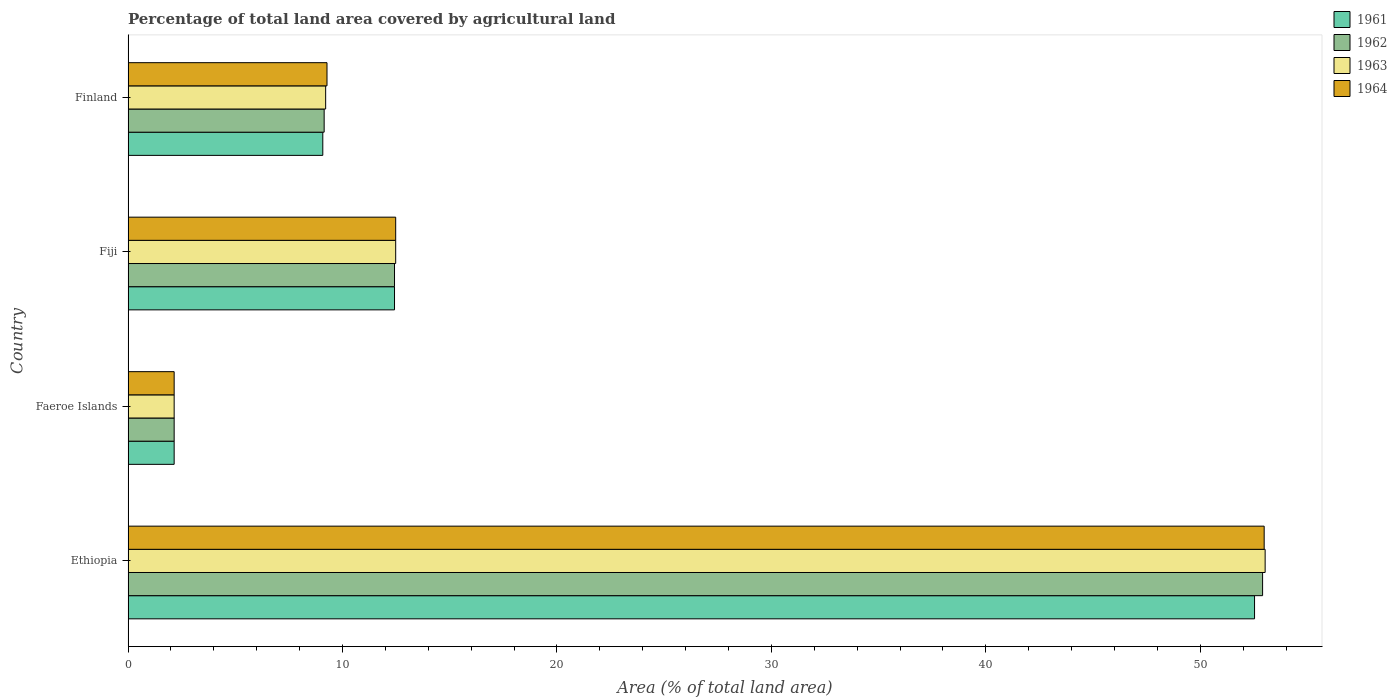How many groups of bars are there?
Keep it short and to the point. 4. Are the number of bars on each tick of the Y-axis equal?
Offer a very short reply. Yes. How many bars are there on the 2nd tick from the bottom?
Ensure brevity in your answer.  4. What is the label of the 4th group of bars from the top?
Keep it short and to the point. Ethiopia. In how many cases, is the number of bars for a given country not equal to the number of legend labels?
Give a very brief answer. 0. What is the percentage of agricultural land in 1961 in Ethiopia?
Keep it short and to the point. 52.53. Across all countries, what is the maximum percentage of agricultural land in 1964?
Give a very brief answer. 52.98. Across all countries, what is the minimum percentage of agricultural land in 1963?
Your answer should be very brief. 2.15. In which country was the percentage of agricultural land in 1963 maximum?
Ensure brevity in your answer.  Ethiopia. In which country was the percentage of agricultural land in 1961 minimum?
Your answer should be very brief. Faeroe Islands. What is the total percentage of agricultural land in 1963 in the graph?
Offer a terse response. 76.87. What is the difference between the percentage of agricultural land in 1961 in Fiji and that in Finland?
Ensure brevity in your answer.  3.34. What is the difference between the percentage of agricultural land in 1961 in Fiji and the percentage of agricultural land in 1964 in Ethiopia?
Provide a short and direct response. -40.55. What is the average percentage of agricultural land in 1964 per country?
Ensure brevity in your answer.  19.22. In how many countries, is the percentage of agricultural land in 1964 greater than 46 %?
Your answer should be very brief. 1. What is the ratio of the percentage of agricultural land in 1962 in Ethiopia to that in Faeroe Islands?
Offer a very short reply. 24.62. Is the difference between the percentage of agricultural land in 1963 in Faeroe Islands and Fiji greater than the difference between the percentage of agricultural land in 1962 in Faeroe Islands and Fiji?
Provide a succinct answer. No. What is the difference between the highest and the second highest percentage of agricultural land in 1963?
Your answer should be very brief. 40.55. What is the difference between the highest and the lowest percentage of agricultural land in 1962?
Provide a short and direct response. 50.76. Is the sum of the percentage of agricultural land in 1962 in Faeroe Islands and Fiji greater than the maximum percentage of agricultural land in 1964 across all countries?
Keep it short and to the point. No. Is it the case that in every country, the sum of the percentage of agricultural land in 1962 and percentage of agricultural land in 1964 is greater than the sum of percentage of agricultural land in 1963 and percentage of agricultural land in 1961?
Provide a succinct answer. No. What does the 4th bar from the bottom in Ethiopia represents?
Make the answer very short. 1964. How many bars are there?
Your answer should be compact. 16. Are all the bars in the graph horizontal?
Provide a succinct answer. Yes. Where does the legend appear in the graph?
Your response must be concise. Top right. How many legend labels are there?
Ensure brevity in your answer.  4. How are the legend labels stacked?
Provide a succinct answer. Vertical. What is the title of the graph?
Ensure brevity in your answer.  Percentage of total land area covered by agricultural land. What is the label or title of the X-axis?
Keep it short and to the point. Area (% of total land area). What is the Area (% of total land area) in 1961 in Ethiopia?
Your answer should be compact. 52.53. What is the Area (% of total land area) in 1962 in Ethiopia?
Provide a succinct answer. 52.91. What is the Area (% of total land area) of 1963 in Ethiopia?
Ensure brevity in your answer.  53.02. What is the Area (% of total land area) of 1964 in Ethiopia?
Offer a very short reply. 52.98. What is the Area (% of total land area) in 1961 in Faeroe Islands?
Provide a succinct answer. 2.15. What is the Area (% of total land area) in 1962 in Faeroe Islands?
Give a very brief answer. 2.15. What is the Area (% of total land area) of 1963 in Faeroe Islands?
Provide a succinct answer. 2.15. What is the Area (% of total land area) in 1964 in Faeroe Islands?
Offer a very short reply. 2.15. What is the Area (% of total land area) in 1961 in Fiji?
Make the answer very short. 12.42. What is the Area (% of total land area) of 1962 in Fiji?
Offer a terse response. 12.42. What is the Area (% of total land area) of 1963 in Fiji?
Offer a very short reply. 12.48. What is the Area (% of total land area) of 1964 in Fiji?
Provide a succinct answer. 12.48. What is the Area (% of total land area) of 1961 in Finland?
Make the answer very short. 9.08. What is the Area (% of total land area) of 1962 in Finland?
Keep it short and to the point. 9.14. What is the Area (% of total land area) in 1963 in Finland?
Provide a short and direct response. 9.21. What is the Area (% of total land area) of 1964 in Finland?
Ensure brevity in your answer.  9.28. Across all countries, what is the maximum Area (% of total land area) of 1961?
Provide a succinct answer. 52.53. Across all countries, what is the maximum Area (% of total land area) of 1962?
Ensure brevity in your answer.  52.91. Across all countries, what is the maximum Area (% of total land area) of 1963?
Ensure brevity in your answer.  53.02. Across all countries, what is the maximum Area (% of total land area) in 1964?
Offer a very short reply. 52.98. Across all countries, what is the minimum Area (% of total land area) in 1961?
Ensure brevity in your answer.  2.15. Across all countries, what is the minimum Area (% of total land area) in 1962?
Your answer should be compact. 2.15. Across all countries, what is the minimum Area (% of total land area) of 1963?
Your response must be concise. 2.15. Across all countries, what is the minimum Area (% of total land area) of 1964?
Provide a succinct answer. 2.15. What is the total Area (% of total land area) in 1961 in the graph?
Your response must be concise. 76.18. What is the total Area (% of total land area) of 1962 in the graph?
Provide a succinct answer. 76.62. What is the total Area (% of total land area) of 1963 in the graph?
Make the answer very short. 76.87. What is the total Area (% of total land area) of 1964 in the graph?
Make the answer very short. 76.88. What is the difference between the Area (% of total land area) of 1961 in Ethiopia and that in Faeroe Islands?
Provide a short and direct response. 50.38. What is the difference between the Area (% of total land area) of 1962 in Ethiopia and that in Faeroe Islands?
Offer a very short reply. 50.76. What is the difference between the Area (% of total land area) of 1963 in Ethiopia and that in Faeroe Islands?
Keep it short and to the point. 50.88. What is the difference between the Area (% of total land area) of 1964 in Ethiopia and that in Faeroe Islands?
Offer a terse response. 50.83. What is the difference between the Area (% of total land area) in 1961 in Ethiopia and that in Fiji?
Your answer should be very brief. 40.11. What is the difference between the Area (% of total land area) in 1962 in Ethiopia and that in Fiji?
Provide a succinct answer. 40.48. What is the difference between the Area (% of total land area) in 1963 in Ethiopia and that in Fiji?
Your answer should be very brief. 40.55. What is the difference between the Area (% of total land area) in 1964 in Ethiopia and that in Fiji?
Your answer should be very brief. 40.5. What is the difference between the Area (% of total land area) of 1961 in Ethiopia and that in Finland?
Provide a succinct answer. 43.45. What is the difference between the Area (% of total land area) of 1962 in Ethiopia and that in Finland?
Your answer should be compact. 43.76. What is the difference between the Area (% of total land area) of 1963 in Ethiopia and that in Finland?
Keep it short and to the point. 43.81. What is the difference between the Area (% of total land area) in 1964 in Ethiopia and that in Finland?
Ensure brevity in your answer.  43.7. What is the difference between the Area (% of total land area) of 1961 in Faeroe Islands and that in Fiji?
Your answer should be compact. -10.28. What is the difference between the Area (% of total land area) in 1962 in Faeroe Islands and that in Fiji?
Ensure brevity in your answer.  -10.28. What is the difference between the Area (% of total land area) of 1963 in Faeroe Islands and that in Fiji?
Your answer should be compact. -10.33. What is the difference between the Area (% of total land area) of 1964 in Faeroe Islands and that in Fiji?
Provide a succinct answer. -10.33. What is the difference between the Area (% of total land area) in 1961 in Faeroe Islands and that in Finland?
Make the answer very short. -6.93. What is the difference between the Area (% of total land area) of 1962 in Faeroe Islands and that in Finland?
Provide a short and direct response. -6.99. What is the difference between the Area (% of total land area) in 1963 in Faeroe Islands and that in Finland?
Ensure brevity in your answer.  -7.07. What is the difference between the Area (% of total land area) in 1964 in Faeroe Islands and that in Finland?
Offer a very short reply. -7.13. What is the difference between the Area (% of total land area) of 1961 in Fiji and that in Finland?
Ensure brevity in your answer.  3.34. What is the difference between the Area (% of total land area) in 1962 in Fiji and that in Finland?
Your answer should be compact. 3.28. What is the difference between the Area (% of total land area) of 1963 in Fiji and that in Finland?
Your answer should be compact. 3.27. What is the difference between the Area (% of total land area) of 1964 in Fiji and that in Finland?
Provide a succinct answer. 3.2. What is the difference between the Area (% of total land area) of 1961 in Ethiopia and the Area (% of total land area) of 1962 in Faeroe Islands?
Provide a short and direct response. 50.38. What is the difference between the Area (% of total land area) in 1961 in Ethiopia and the Area (% of total land area) in 1963 in Faeroe Islands?
Your response must be concise. 50.38. What is the difference between the Area (% of total land area) of 1961 in Ethiopia and the Area (% of total land area) of 1964 in Faeroe Islands?
Make the answer very short. 50.38. What is the difference between the Area (% of total land area) in 1962 in Ethiopia and the Area (% of total land area) in 1963 in Faeroe Islands?
Give a very brief answer. 50.76. What is the difference between the Area (% of total land area) in 1962 in Ethiopia and the Area (% of total land area) in 1964 in Faeroe Islands?
Give a very brief answer. 50.76. What is the difference between the Area (% of total land area) of 1963 in Ethiopia and the Area (% of total land area) of 1964 in Faeroe Islands?
Provide a succinct answer. 50.88. What is the difference between the Area (% of total land area) in 1961 in Ethiopia and the Area (% of total land area) in 1962 in Fiji?
Make the answer very short. 40.11. What is the difference between the Area (% of total land area) in 1961 in Ethiopia and the Area (% of total land area) in 1963 in Fiji?
Your answer should be very brief. 40.05. What is the difference between the Area (% of total land area) of 1961 in Ethiopia and the Area (% of total land area) of 1964 in Fiji?
Your answer should be compact. 40.05. What is the difference between the Area (% of total land area) of 1962 in Ethiopia and the Area (% of total land area) of 1963 in Fiji?
Offer a very short reply. 40.43. What is the difference between the Area (% of total land area) of 1962 in Ethiopia and the Area (% of total land area) of 1964 in Fiji?
Offer a very short reply. 40.43. What is the difference between the Area (% of total land area) of 1963 in Ethiopia and the Area (% of total land area) of 1964 in Fiji?
Your answer should be very brief. 40.55. What is the difference between the Area (% of total land area) of 1961 in Ethiopia and the Area (% of total land area) of 1962 in Finland?
Ensure brevity in your answer.  43.39. What is the difference between the Area (% of total land area) of 1961 in Ethiopia and the Area (% of total land area) of 1963 in Finland?
Keep it short and to the point. 43.32. What is the difference between the Area (% of total land area) in 1961 in Ethiopia and the Area (% of total land area) in 1964 in Finland?
Offer a terse response. 43.25. What is the difference between the Area (% of total land area) of 1962 in Ethiopia and the Area (% of total land area) of 1963 in Finland?
Make the answer very short. 43.69. What is the difference between the Area (% of total land area) of 1962 in Ethiopia and the Area (% of total land area) of 1964 in Finland?
Provide a short and direct response. 43.63. What is the difference between the Area (% of total land area) of 1963 in Ethiopia and the Area (% of total land area) of 1964 in Finland?
Your response must be concise. 43.75. What is the difference between the Area (% of total land area) in 1961 in Faeroe Islands and the Area (% of total land area) in 1962 in Fiji?
Make the answer very short. -10.28. What is the difference between the Area (% of total land area) of 1961 in Faeroe Islands and the Area (% of total land area) of 1963 in Fiji?
Your answer should be compact. -10.33. What is the difference between the Area (% of total land area) of 1961 in Faeroe Islands and the Area (% of total land area) of 1964 in Fiji?
Provide a succinct answer. -10.33. What is the difference between the Area (% of total land area) in 1962 in Faeroe Islands and the Area (% of total land area) in 1963 in Fiji?
Ensure brevity in your answer.  -10.33. What is the difference between the Area (% of total land area) in 1962 in Faeroe Islands and the Area (% of total land area) in 1964 in Fiji?
Offer a very short reply. -10.33. What is the difference between the Area (% of total land area) in 1963 in Faeroe Islands and the Area (% of total land area) in 1964 in Fiji?
Keep it short and to the point. -10.33. What is the difference between the Area (% of total land area) of 1961 in Faeroe Islands and the Area (% of total land area) of 1962 in Finland?
Your response must be concise. -6.99. What is the difference between the Area (% of total land area) in 1961 in Faeroe Islands and the Area (% of total land area) in 1963 in Finland?
Your answer should be compact. -7.07. What is the difference between the Area (% of total land area) in 1961 in Faeroe Islands and the Area (% of total land area) in 1964 in Finland?
Offer a terse response. -7.13. What is the difference between the Area (% of total land area) of 1962 in Faeroe Islands and the Area (% of total land area) of 1963 in Finland?
Provide a succinct answer. -7.07. What is the difference between the Area (% of total land area) in 1962 in Faeroe Islands and the Area (% of total land area) in 1964 in Finland?
Provide a short and direct response. -7.13. What is the difference between the Area (% of total land area) of 1963 in Faeroe Islands and the Area (% of total land area) of 1964 in Finland?
Your answer should be compact. -7.13. What is the difference between the Area (% of total land area) of 1961 in Fiji and the Area (% of total land area) of 1962 in Finland?
Offer a very short reply. 3.28. What is the difference between the Area (% of total land area) in 1961 in Fiji and the Area (% of total land area) in 1963 in Finland?
Offer a terse response. 3.21. What is the difference between the Area (% of total land area) of 1961 in Fiji and the Area (% of total land area) of 1964 in Finland?
Offer a terse response. 3.15. What is the difference between the Area (% of total land area) in 1962 in Fiji and the Area (% of total land area) in 1963 in Finland?
Your answer should be very brief. 3.21. What is the difference between the Area (% of total land area) of 1962 in Fiji and the Area (% of total land area) of 1964 in Finland?
Offer a very short reply. 3.15. What is the difference between the Area (% of total land area) in 1963 in Fiji and the Area (% of total land area) in 1964 in Finland?
Your answer should be compact. 3.2. What is the average Area (% of total land area) of 1961 per country?
Your answer should be very brief. 19.05. What is the average Area (% of total land area) of 1962 per country?
Your answer should be very brief. 19.16. What is the average Area (% of total land area) of 1963 per country?
Offer a very short reply. 19.22. What is the average Area (% of total land area) of 1964 per country?
Offer a terse response. 19.22. What is the difference between the Area (% of total land area) of 1961 and Area (% of total land area) of 1962 in Ethiopia?
Make the answer very short. -0.38. What is the difference between the Area (% of total land area) in 1961 and Area (% of total land area) in 1963 in Ethiopia?
Provide a short and direct response. -0.49. What is the difference between the Area (% of total land area) of 1961 and Area (% of total land area) of 1964 in Ethiopia?
Provide a succinct answer. -0.45. What is the difference between the Area (% of total land area) in 1962 and Area (% of total land area) in 1963 in Ethiopia?
Provide a succinct answer. -0.12. What is the difference between the Area (% of total land area) of 1962 and Area (% of total land area) of 1964 in Ethiopia?
Ensure brevity in your answer.  -0.07. What is the difference between the Area (% of total land area) of 1963 and Area (% of total land area) of 1964 in Ethiopia?
Make the answer very short. 0.05. What is the difference between the Area (% of total land area) in 1961 and Area (% of total land area) in 1964 in Faeroe Islands?
Your answer should be compact. 0. What is the difference between the Area (% of total land area) in 1962 and Area (% of total land area) in 1963 in Faeroe Islands?
Make the answer very short. 0. What is the difference between the Area (% of total land area) in 1961 and Area (% of total land area) in 1962 in Fiji?
Your answer should be compact. 0. What is the difference between the Area (% of total land area) of 1961 and Area (% of total land area) of 1963 in Fiji?
Make the answer very short. -0.05. What is the difference between the Area (% of total land area) of 1961 and Area (% of total land area) of 1964 in Fiji?
Offer a very short reply. -0.05. What is the difference between the Area (% of total land area) of 1962 and Area (% of total land area) of 1963 in Fiji?
Your response must be concise. -0.05. What is the difference between the Area (% of total land area) of 1962 and Area (% of total land area) of 1964 in Fiji?
Your answer should be compact. -0.05. What is the difference between the Area (% of total land area) in 1963 and Area (% of total land area) in 1964 in Fiji?
Keep it short and to the point. 0. What is the difference between the Area (% of total land area) of 1961 and Area (% of total land area) of 1962 in Finland?
Ensure brevity in your answer.  -0.06. What is the difference between the Area (% of total land area) in 1961 and Area (% of total land area) in 1963 in Finland?
Offer a very short reply. -0.13. What is the difference between the Area (% of total land area) of 1961 and Area (% of total land area) of 1964 in Finland?
Offer a terse response. -0.2. What is the difference between the Area (% of total land area) in 1962 and Area (% of total land area) in 1963 in Finland?
Keep it short and to the point. -0.07. What is the difference between the Area (% of total land area) in 1962 and Area (% of total land area) in 1964 in Finland?
Offer a terse response. -0.13. What is the difference between the Area (% of total land area) in 1963 and Area (% of total land area) in 1964 in Finland?
Ensure brevity in your answer.  -0.06. What is the ratio of the Area (% of total land area) of 1961 in Ethiopia to that in Faeroe Islands?
Provide a short and direct response. 24.44. What is the ratio of the Area (% of total land area) in 1962 in Ethiopia to that in Faeroe Islands?
Your answer should be compact. 24.62. What is the ratio of the Area (% of total land area) in 1963 in Ethiopia to that in Faeroe Islands?
Your answer should be compact. 24.67. What is the ratio of the Area (% of total land area) of 1964 in Ethiopia to that in Faeroe Islands?
Provide a short and direct response. 24.65. What is the ratio of the Area (% of total land area) in 1961 in Ethiopia to that in Fiji?
Keep it short and to the point. 4.23. What is the ratio of the Area (% of total land area) in 1962 in Ethiopia to that in Fiji?
Your answer should be compact. 4.26. What is the ratio of the Area (% of total land area) of 1963 in Ethiopia to that in Fiji?
Your response must be concise. 4.25. What is the ratio of the Area (% of total land area) of 1964 in Ethiopia to that in Fiji?
Your response must be concise. 4.25. What is the ratio of the Area (% of total land area) of 1961 in Ethiopia to that in Finland?
Provide a succinct answer. 5.79. What is the ratio of the Area (% of total land area) of 1962 in Ethiopia to that in Finland?
Keep it short and to the point. 5.79. What is the ratio of the Area (% of total land area) of 1963 in Ethiopia to that in Finland?
Give a very brief answer. 5.75. What is the ratio of the Area (% of total land area) in 1964 in Ethiopia to that in Finland?
Ensure brevity in your answer.  5.71. What is the ratio of the Area (% of total land area) of 1961 in Faeroe Islands to that in Fiji?
Give a very brief answer. 0.17. What is the ratio of the Area (% of total land area) of 1962 in Faeroe Islands to that in Fiji?
Your response must be concise. 0.17. What is the ratio of the Area (% of total land area) of 1963 in Faeroe Islands to that in Fiji?
Provide a short and direct response. 0.17. What is the ratio of the Area (% of total land area) of 1964 in Faeroe Islands to that in Fiji?
Ensure brevity in your answer.  0.17. What is the ratio of the Area (% of total land area) in 1961 in Faeroe Islands to that in Finland?
Provide a succinct answer. 0.24. What is the ratio of the Area (% of total land area) of 1962 in Faeroe Islands to that in Finland?
Offer a terse response. 0.23. What is the ratio of the Area (% of total land area) of 1963 in Faeroe Islands to that in Finland?
Keep it short and to the point. 0.23. What is the ratio of the Area (% of total land area) of 1964 in Faeroe Islands to that in Finland?
Make the answer very short. 0.23. What is the ratio of the Area (% of total land area) in 1961 in Fiji to that in Finland?
Provide a short and direct response. 1.37. What is the ratio of the Area (% of total land area) in 1962 in Fiji to that in Finland?
Offer a terse response. 1.36. What is the ratio of the Area (% of total land area) in 1963 in Fiji to that in Finland?
Keep it short and to the point. 1.35. What is the ratio of the Area (% of total land area) of 1964 in Fiji to that in Finland?
Keep it short and to the point. 1.35. What is the difference between the highest and the second highest Area (% of total land area) of 1961?
Make the answer very short. 40.11. What is the difference between the highest and the second highest Area (% of total land area) in 1962?
Give a very brief answer. 40.48. What is the difference between the highest and the second highest Area (% of total land area) in 1963?
Keep it short and to the point. 40.55. What is the difference between the highest and the second highest Area (% of total land area) of 1964?
Give a very brief answer. 40.5. What is the difference between the highest and the lowest Area (% of total land area) in 1961?
Provide a short and direct response. 50.38. What is the difference between the highest and the lowest Area (% of total land area) of 1962?
Ensure brevity in your answer.  50.76. What is the difference between the highest and the lowest Area (% of total land area) of 1963?
Offer a very short reply. 50.88. What is the difference between the highest and the lowest Area (% of total land area) of 1964?
Ensure brevity in your answer.  50.83. 